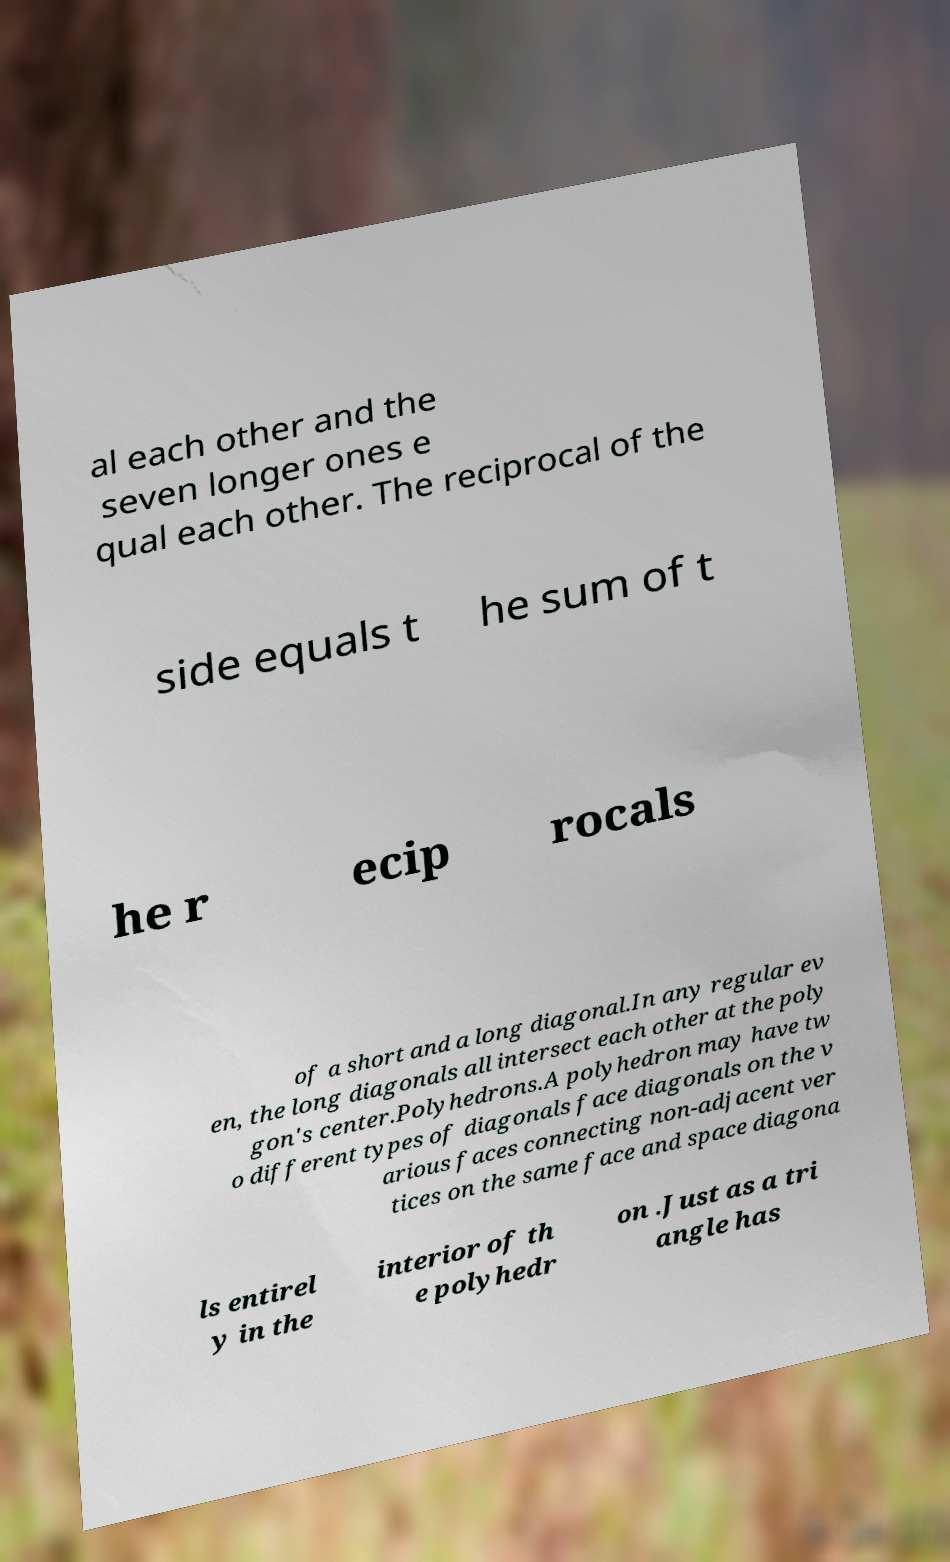There's text embedded in this image that I need extracted. Can you transcribe it verbatim? al each other and the seven longer ones e qual each other. The reciprocal of the side equals t he sum of t he r ecip rocals of a short and a long diagonal.In any regular ev en, the long diagonals all intersect each other at the poly gon's center.Polyhedrons.A polyhedron may have tw o different types of diagonals face diagonals on the v arious faces connecting non-adjacent ver tices on the same face and space diagona ls entirel y in the interior of th e polyhedr on .Just as a tri angle has 